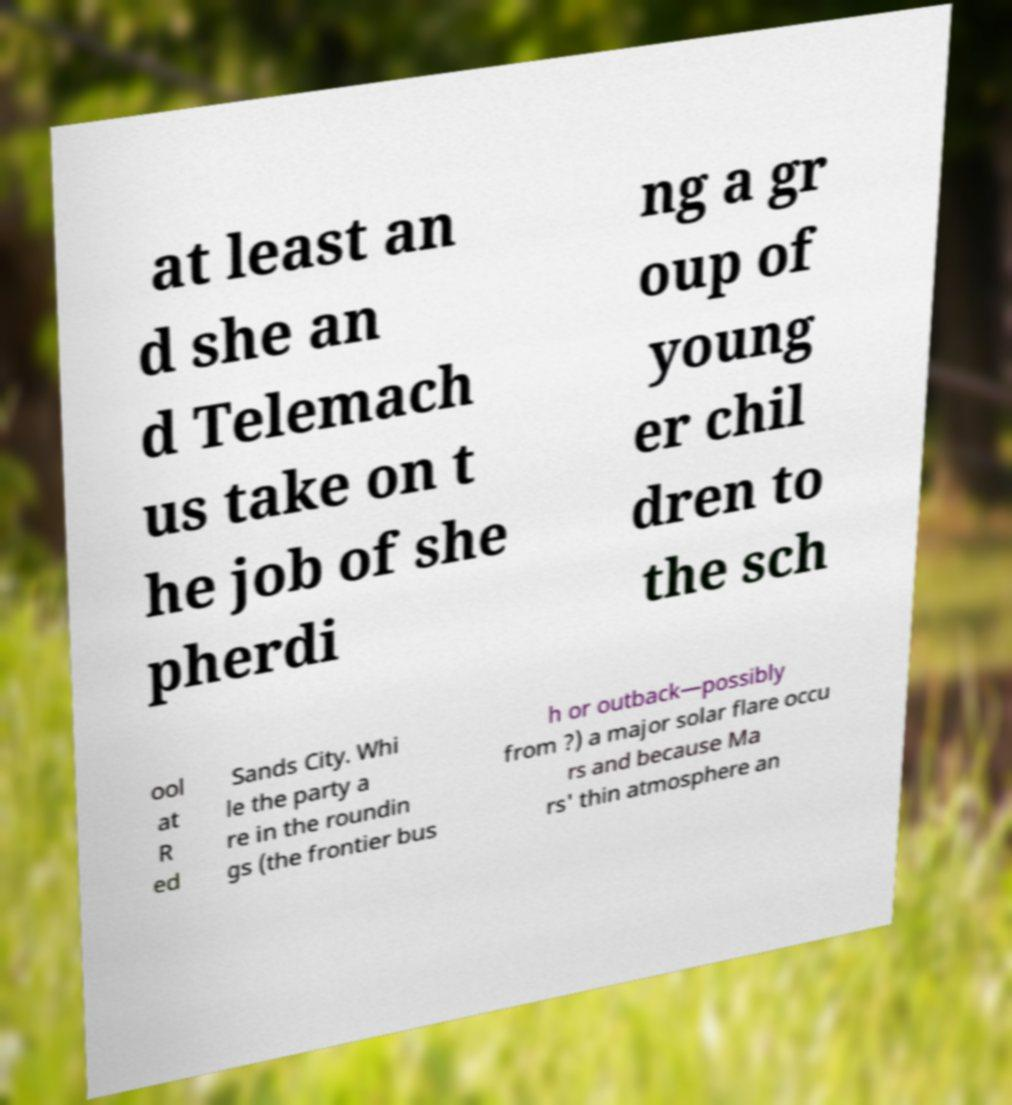Can you read and provide the text displayed in the image?This photo seems to have some interesting text. Can you extract and type it out for me? at least an d she an d Telemach us take on t he job of she pherdi ng a gr oup of young er chil dren to the sch ool at R ed Sands City. Whi le the party a re in the roundin gs (the frontier bus h or outback—possibly from ?) a major solar flare occu rs and because Ma rs' thin atmosphere an 